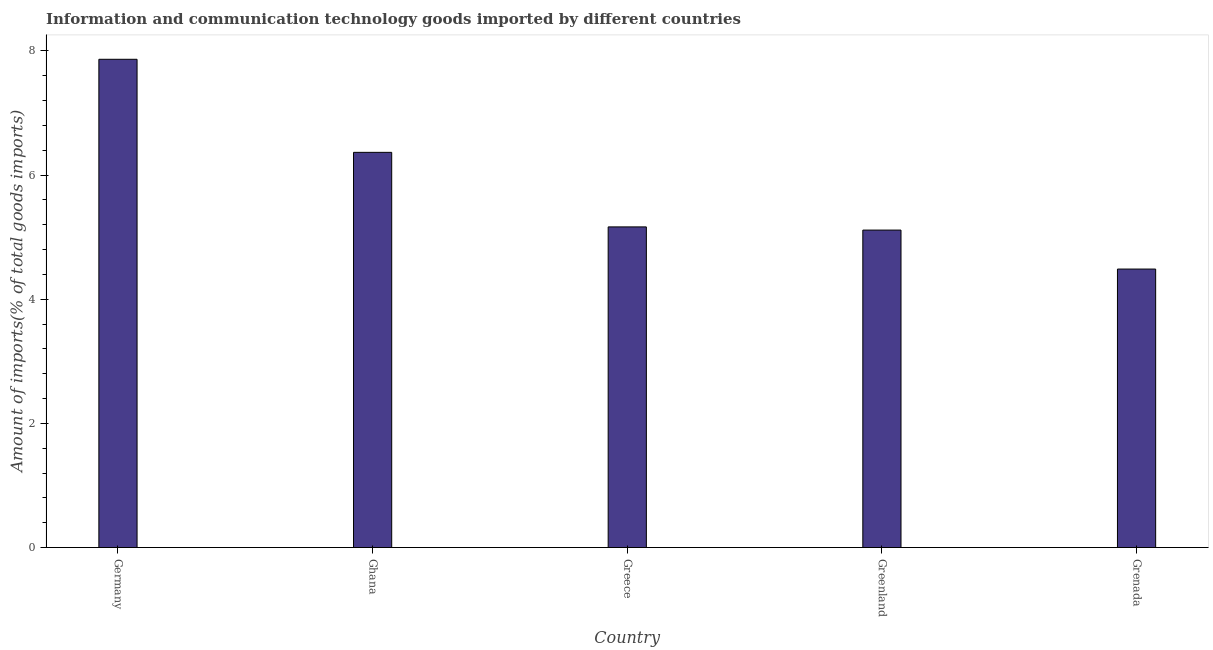Does the graph contain grids?
Offer a very short reply. No. What is the title of the graph?
Make the answer very short. Information and communication technology goods imported by different countries. What is the label or title of the Y-axis?
Ensure brevity in your answer.  Amount of imports(% of total goods imports). What is the amount of ict goods imports in Germany?
Your answer should be very brief. 7.87. Across all countries, what is the maximum amount of ict goods imports?
Your answer should be very brief. 7.87. Across all countries, what is the minimum amount of ict goods imports?
Provide a short and direct response. 4.49. In which country was the amount of ict goods imports maximum?
Make the answer very short. Germany. In which country was the amount of ict goods imports minimum?
Offer a terse response. Grenada. What is the sum of the amount of ict goods imports?
Your answer should be compact. 29. What is the difference between the amount of ict goods imports in Ghana and Greece?
Offer a very short reply. 1.2. What is the average amount of ict goods imports per country?
Your answer should be compact. 5.8. What is the median amount of ict goods imports?
Keep it short and to the point. 5.17. What is the ratio of the amount of ict goods imports in Ghana to that in Grenada?
Make the answer very short. 1.42. Is the difference between the amount of ict goods imports in Ghana and Greece greater than the difference between any two countries?
Offer a very short reply. No. What is the difference between the highest and the second highest amount of ict goods imports?
Your answer should be very brief. 1.5. Is the sum of the amount of ict goods imports in Ghana and Greenland greater than the maximum amount of ict goods imports across all countries?
Your answer should be compact. Yes. What is the difference between the highest and the lowest amount of ict goods imports?
Offer a terse response. 3.38. In how many countries, is the amount of ict goods imports greater than the average amount of ict goods imports taken over all countries?
Give a very brief answer. 2. How many bars are there?
Offer a very short reply. 5. How many countries are there in the graph?
Your answer should be very brief. 5. Are the values on the major ticks of Y-axis written in scientific E-notation?
Make the answer very short. No. What is the Amount of imports(% of total goods imports) in Germany?
Offer a very short reply. 7.87. What is the Amount of imports(% of total goods imports) of Ghana?
Your response must be concise. 6.37. What is the Amount of imports(% of total goods imports) in Greece?
Offer a very short reply. 5.17. What is the Amount of imports(% of total goods imports) of Greenland?
Your answer should be very brief. 5.11. What is the Amount of imports(% of total goods imports) of Grenada?
Your answer should be compact. 4.49. What is the difference between the Amount of imports(% of total goods imports) in Germany and Ghana?
Offer a terse response. 1.5. What is the difference between the Amount of imports(% of total goods imports) in Germany and Greece?
Give a very brief answer. 2.7. What is the difference between the Amount of imports(% of total goods imports) in Germany and Greenland?
Provide a short and direct response. 2.75. What is the difference between the Amount of imports(% of total goods imports) in Germany and Grenada?
Keep it short and to the point. 3.38. What is the difference between the Amount of imports(% of total goods imports) in Ghana and Greece?
Your response must be concise. 1.2. What is the difference between the Amount of imports(% of total goods imports) in Ghana and Greenland?
Your answer should be compact. 1.25. What is the difference between the Amount of imports(% of total goods imports) in Ghana and Grenada?
Make the answer very short. 1.88. What is the difference between the Amount of imports(% of total goods imports) in Greece and Greenland?
Provide a short and direct response. 0.05. What is the difference between the Amount of imports(% of total goods imports) in Greece and Grenada?
Ensure brevity in your answer.  0.68. What is the difference between the Amount of imports(% of total goods imports) in Greenland and Grenada?
Ensure brevity in your answer.  0.63. What is the ratio of the Amount of imports(% of total goods imports) in Germany to that in Ghana?
Make the answer very short. 1.24. What is the ratio of the Amount of imports(% of total goods imports) in Germany to that in Greece?
Offer a terse response. 1.52. What is the ratio of the Amount of imports(% of total goods imports) in Germany to that in Greenland?
Keep it short and to the point. 1.54. What is the ratio of the Amount of imports(% of total goods imports) in Germany to that in Grenada?
Offer a terse response. 1.75. What is the ratio of the Amount of imports(% of total goods imports) in Ghana to that in Greece?
Your response must be concise. 1.23. What is the ratio of the Amount of imports(% of total goods imports) in Ghana to that in Greenland?
Keep it short and to the point. 1.25. What is the ratio of the Amount of imports(% of total goods imports) in Ghana to that in Grenada?
Give a very brief answer. 1.42. What is the ratio of the Amount of imports(% of total goods imports) in Greece to that in Grenada?
Your response must be concise. 1.15. What is the ratio of the Amount of imports(% of total goods imports) in Greenland to that in Grenada?
Offer a terse response. 1.14. 